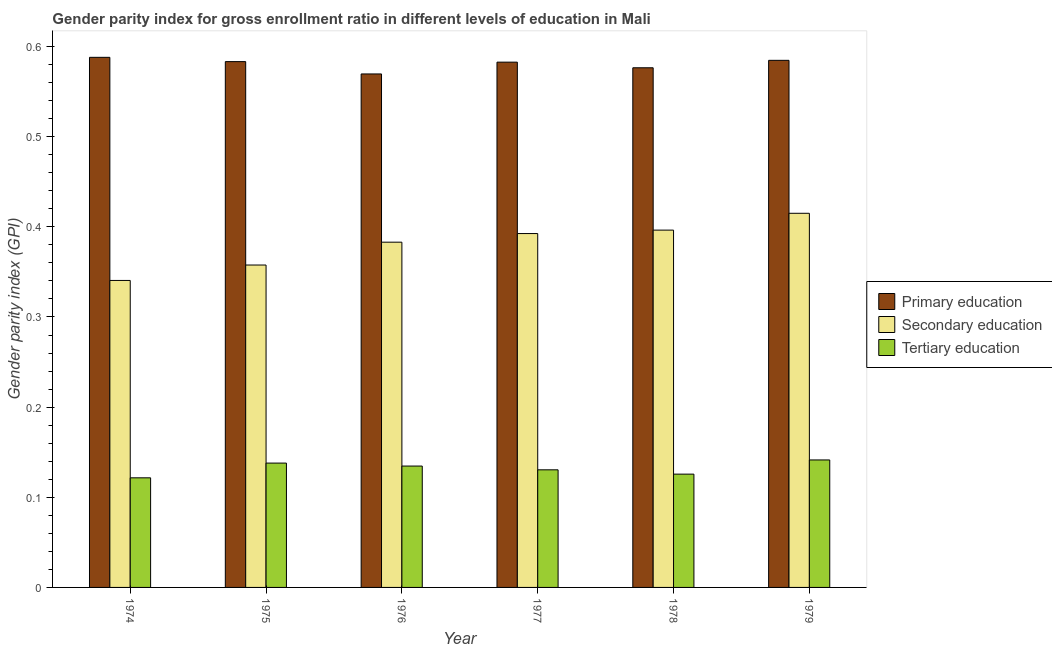How many groups of bars are there?
Your answer should be very brief. 6. Are the number of bars on each tick of the X-axis equal?
Provide a short and direct response. Yes. How many bars are there on the 6th tick from the right?
Make the answer very short. 3. What is the label of the 5th group of bars from the left?
Offer a very short reply. 1978. What is the gender parity index in primary education in 1978?
Offer a terse response. 0.58. Across all years, what is the maximum gender parity index in primary education?
Keep it short and to the point. 0.59. Across all years, what is the minimum gender parity index in primary education?
Make the answer very short. 0.57. In which year was the gender parity index in primary education maximum?
Ensure brevity in your answer.  1974. In which year was the gender parity index in secondary education minimum?
Ensure brevity in your answer.  1974. What is the total gender parity index in secondary education in the graph?
Your answer should be compact. 2.29. What is the difference between the gender parity index in primary education in 1974 and that in 1979?
Keep it short and to the point. 0. What is the difference between the gender parity index in secondary education in 1975 and the gender parity index in primary education in 1976?
Provide a succinct answer. -0.03. What is the average gender parity index in primary education per year?
Your response must be concise. 0.58. In the year 1974, what is the difference between the gender parity index in secondary education and gender parity index in primary education?
Provide a succinct answer. 0. In how many years, is the gender parity index in primary education greater than 0.22?
Keep it short and to the point. 6. What is the ratio of the gender parity index in secondary education in 1975 to that in 1977?
Your answer should be very brief. 0.91. Is the gender parity index in tertiary education in 1977 less than that in 1978?
Your answer should be compact. No. What is the difference between the highest and the second highest gender parity index in secondary education?
Make the answer very short. 0.02. What is the difference between the highest and the lowest gender parity index in secondary education?
Offer a very short reply. 0.07. In how many years, is the gender parity index in tertiary education greater than the average gender parity index in tertiary education taken over all years?
Your response must be concise. 3. Is the sum of the gender parity index in tertiary education in 1974 and 1976 greater than the maximum gender parity index in primary education across all years?
Your answer should be very brief. Yes. What does the 2nd bar from the left in 1979 represents?
Your response must be concise. Secondary education. What does the 3rd bar from the right in 1976 represents?
Give a very brief answer. Primary education. Is it the case that in every year, the sum of the gender parity index in primary education and gender parity index in secondary education is greater than the gender parity index in tertiary education?
Offer a very short reply. Yes. How many years are there in the graph?
Offer a terse response. 6. What is the difference between two consecutive major ticks on the Y-axis?
Keep it short and to the point. 0.1. Are the values on the major ticks of Y-axis written in scientific E-notation?
Offer a very short reply. No. Does the graph contain grids?
Offer a very short reply. No. How many legend labels are there?
Make the answer very short. 3. How are the legend labels stacked?
Ensure brevity in your answer.  Vertical. What is the title of the graph?
Give a very brief answer. Gender parity index for gross enrollment ratio in different levels of education in Mali. What is the label or title of the X-axis?
Your response must be concise. Year. What is the label or title of the Y-axis?
Ensure brevity in your answer.  Gender parity index (GPI). What is the Gender parity index (GPI) in Primary education in 1974?
Your answer should be very brief. 0.59. What is the Gender parity index (GPI) of Secondary education in 1974?
Offer a terse response. 0.34. What is the Gender parity index (GPI) in Tertiary education in 1974?
Your answer should be very brief. 0.12. What is the Gender parity index (GPI) of Primary education in 1975?
Offer a very short reply. 0.58. What is the Gender parity index (GPI) of Secondary education in 1975?
Your answer should be very brief. 0.36. What is the Gender parity index (GPI) in Tertiary education in 1975?
Give a very brief answer. 0.14. What is the Gender parity index (GPI) of Primary education in 1976?
Your response must be concise. 0.57. What is the Gender parity index (GPI) in Secondary education in 1976?
Provide a short and direct response. 0.38. What is the Gender parity index (GPI) of Tertiary education in 1976?
Keep it short and to the point. 0.13. What is the Gender parity index (GPI) of Primary education in 1977?
Provide a succinct answer. 0.58. What is the Gender parity index (GPI) in Secondary education in 1977?
Offer a terse response. 0.39. What is the Gender parity index (GPI) of Tertiary education in 1977?
Your response must be concise. 0.13. What is the Gender parity index (GPI) of Primary education in 1978?
Your answer should be very brief. 0.58. What is the Gender parity index (GPI) in Secondary education in 1978?
Offer a very short reply. 0.4. What is the Gender parity index (GPI) in Tertiary education in 1978?
Ensure brevity in your answer.  0.13. What is the Gender parity index (GPI) of Primary education in 1979?
Offer a very short reply. 0.58. What is the Gender parity index (GPI) in Secondary education in 1979?
Provide a short and direct response. 0.42. What is the Gender parity index (GPI) in Tertiary education in 1979?
Your response must be concise. 0.14. Across all years, what is the maximum Gender parity index (GPI) in Primary education?
Your answer should be compact. 0.59. Across all years, what is the maximum Gender parity index (GPI) of Secondary education?
Provide a short and direct response. 0.42. Across all years, what is the maximum Gender parity index (GPI) of Tertiary education?
Ensure brevity in your answer.  0.14. Across all years, what is the minimum Gender parity index (GPI) in Primary education?
Offer a very short reply. 0.57. Across all years, what is the minimum Gender parity index (GPI) in Secondary education?
Provide a succinct answer. 0.34. Across all years, what is the minimum Gender parity index (GPI) of Tertiary education?
Give a very brief answer. 0.12. What is the total Gender parity index (GPI) of Primary education in the graph?
Give a very brief answer. 3.48. What is the total Gender parity index (GPI) of Secondary education in the graph?
Your answer should be very brief. 2.29. What is the total Gender parity index (GPI) of Tertiary education in the graph?
Keep it short and to the point. 0.79. What is the difference between the Gender parity index (GPI) in Primary education in 1974 and that in 1975?
Your answer should be compact. 0. What is the difference between the Gender parity index (GPI) of Secondary education in 1974 and that in 1975?
Your response must be concise. -0.02. What is the difference between the Gender parity index (GPI) in Tertiary education in 1974 and that in 1975?
Keep it short and to the point. -0.02. What is the difference between the Gender parity index (GPI) in Primary education in 1974 and that in 1976?
Provide a short and direct response. 0.02. What is the difference between the Gender parity index (GPI) in Secondary education in 1974 and that in 1976?
Your answer should be very brief. -0.04. What is the difference between the Gender parity index (GPI) in Tertiary education in 1974 and that in 1976?
Make the answer very short. -0.01. What is the difference between the Gender parity index (GPI) of Primary education in 1974 and that in 1977?
Keep it short and to the point. 0.01. What is the difference between the Gender parity index (GPI) of Secondary education in 1974 and that in 1977?
Ensure brevity in your answer.  -0.05. What is the difference between the Gender parity index (GPI) of Tertiary education in 1974 and that in 1977?
Offer a terse response. -0.01. What is the difference between the Gender parity index (GPI) in Primary education in 1974 and that in 1978?
Ensure brevity in your answer.  0.01. What is the difference between the Gender parity index (GPI) of Secondary education in 1974 and that in 1978?
Make the answer very short. -0.06. What is the difference between the Gender parity index (GPI) of Tertiary education in 1974 and that in 1978?
Your response must be concise. -0. What is the difference between the Gender parity index (GPI) of Primary education in 1974 and that in 1979?
Your answer should be compact. 0. What is the difference between the Gender parity index (GPI) of Secondary education in 1974 and that in 1979?
Provide a succinct answer. -0.07. What is the difference between the Gender parity index (GPI) of Tertiary education in 1974 and that in 1979?
Your response must be concise. -0.02. What is the difference between the Gender parity index (GPI) of Primary education in 1975 and that in 1976?
Your answer should be compact. 0.01. What is the difference between the Gender parity index (GPI) of Secondary education in 1975 and that in 1976?
Ensure brevity in your answer.  -0.03. What is the difference between the Gender parity index (GPI) of Tertiary education in 1975 and that in 1976?
Offer a terse response. 0. What is the difference between the Gender parity index (GPI) of Primary education in 1975 and that in 1977?
Your response must be concise. 0. What is the difference between the Gender parity index (GPI) of Secondary education in 1975 and that in 1977?
Offer a very short reply. -0.03. What is the difference between the Gender parity index (GPI) in Tertiary education in 1975 and that in 1977?
Your answer should be compact. 0.01. What is the difference between the Gender parity index (GPI) of Primary education in 1975 and that in 1978?
Provide a succinct answer. 0.01. What is the difference between the Gender parity index (GPI) in Secondary education in 1975 and that in 1978?
Your answer should be very brief. -0.04. What is the difference between the Gender parity index (GPI) in Tertiary education in 1975 and that in 1978?
Make the answer very short. 0.01. What is the difference between the Gender parity index (GPI) of Primary education in 1975 and that in 1979?
Keep it short and to the point. -0. What is the difference between the Gender parity index (GPI) in Secondary education in 1975 and that in 1979?
Your answer should be compact. -0.06. What is the difference between the Gender parity index (GPI) of Tertiary education in 1975 and that in 1979?
Your answer should be compact. -0. What is the difference between the Gender parity index (GPI) of Primary education in 1976 and that in 1977?
Keep it short and to the point. -0.01. What is the difference between the Gender parity index (GPI) of Secondary education in 1976 and that in 1977?
Provide a succinct answer. -0.01. What is the difference between the Gender parity index (GPI) in Tertiary education in 1976 and that in 1977?
Provide a succinct answer. 0. What is the difference between the Gender parity index (GPI) of Primary education in 1976 and that in 1978?
Your response must be concise. -0.01. What is the difference between the Gender parity index (GPI) in Secondary education in 1976 and that in 1978?
Provide a succinct answer. -0.01. What is the difference between the Gender parity index (GPI) of Tertiary education in 1976 and that in 1978?
Give a very brief answer. 0.01. What is the difference between the Gender parity index (GPI) of Primary education in 1976 and that in 1979?
Keep it short and to the point. -0.02. What is the difference between the Gender parity index (GPI) of Secondary education in 1976 and that in 1979?
Ensure brevity in your answer.  -0.03. What is the difference between the Gender parity index (GPI) in Tertiary education in 1976 and that in 1979?
Keep it short and to the point. -0.01. What is the difference between the Gender parity index (GPI) of Primary education in 1977 and that in 1978?
Offer a terse response. 0.01. What is the difference between the Gender parity index (GPI) of Secondary education in 1977 and that in 1978?
Offer a terse response. -0. What is the difference between the Gender parity index (GPI) of Tertiary education in 1977 and that in 1978?
Give a very brief answer. 0. What is the difference between the Gender parity index (GPI) of Primary education in 1977 and that in 1979?
Make the answer very short. -0. What is the difference between the Gender parity index (GPI) of Secondary education in 1977 and that in 1979?
Provide a short and direct response. -0.02. What is the difference between the Gender parity index (GPI) in Tertiary education in 1977 and that in 1979?
Provide a short and direct response. -0.01. What is the difference between the Gender parity index (GPI) of Primary education in 1978 and that in 1979?
Provide a short and direct response. -0.01. What is the difference between the Gender parity index (GPI) in Secondary education in 1978 and that in 1979?
Ensure brevity in your answer.  -0.02. What is the difference between the Gender parity index (GPI) of Tertiary education in 1978 and that in 1979?
Make the answer very short. -0.02. What is the difference between the Gender parity index (GPI) in Primary education in 1974 and the Gender parity index (GPI) in Secondary education in 1975?
Your answer should be compact. 0.23. What is the difference between the Gender parity index (GPI) of Primary education in 1974 and the Gender parity index (GPI) of Tertiary education in 1975?
Make the answer very short. 0.45. What is the difference between the Gender parity index (GPI) in Secondary education in 1974 and the Gender parity index (GPI) in Tertiary education in 1975?
Your answer should be very brief. 0.2. What is the difference between the Gender parity index (GPI) in Primary education in 1974 and the Gender parity index (GPI) in Secondary education in 1976?
Give a very brief answer. 0.21. What is the difference between the Gender parity index (GPI) in Primary education in 1974 and the Gender parity index (GPI) in Tertiary education in 1976?
Provide a succinct answer. 0.45. What is the difference between the Gender parity index (GPI) of Secondary education in 1974 and the Gender parity index (GPI) of Tertiary education in 1976?
Provide a short and direct response. 0.21. What is the difference between the Gender parity index (GPI) of Primary education in 1974 and the Gender parity index (GPI) of Secondary education in 1977?
Your answer should be compact. 0.2. What is the difference between the Gender parity index (GPI) in Primary education in 1974 and the Gender parity index (GPI) in Tertiary education in 1977?
Give a very brief answer. 0.46. What is the difference between the Gender parity index (GPI) of Secondary education in 1974 and the Gender parity index (GPI) of Tertiary education in 1977?
Provide a succinct answer. 0.21. What is the difference between the Gender parity index (GPI) in Primary education in 1974 and the Gender parity index (GPI) in Secondary education in 1978?
Your answer should be very brief. 0.19. What is the difference between the Gender parity index (GPI) of Primary education in 1974 and the Gender parity index (GPI) of Tertiary education in 1978?
Your answer should be very brief. 0.46. What is the difference between the Gender parity index (GPI) in Secondary education in 1974 and the Gender parity index (GPI) in Tertiary education in 1978?
Keep it short and to the point. 0.21. What is the difference between the Gender parity index (GPI) in Primary education in 1974 and the Gender parity index (GPI) in Secondary education in 1979?
Ensure brevity in your answer.  0.17. What is the difference between the Gender parity index (GPI) of Primary education in 1974 and the Gender parity index (GPI) of Tertiary education in 1979?
Keep it short and to the point. 0.45. What is the difference between the Gender parity index (GPI) in Secondary education in 1974 and the Gender parity index (GPI) in Tertiary education in 1979?
Offer a terse response. 0.2. What is the difference between the Gender parity index (GPI) in Primary education in 1975 and the Gender parity index (GPI) in Secondary education in 1976?
Your response must be concise. 0.2. What is the difference between the Gender parity index (GPI) in Primary education in 1975 and the Gender parity index (GPI) in Tertiary education in 1976?
Offer a terse response. 0.45. What is the difference between the Gender parity index (GPI) in Secondary education in 1975 and the Gender parity index (GPI) in Tertiary education in 1976?
Your answer should be very brief. 0.22. What is the difference between the Gender parity index (GPI) in Primary education in 1975 and the Gender parity index (GPI) in Secondary education in 1977?
Your answer should be very brief. 0.19. What is the difference between the Gender parity index (GPI) of Primary education in 1975 and the Gender parity index (GPI) of Tertiary education in 1977?
Your response must be concise. 0.45. What is the difference between the Gender parity index (GPI) in Secondary education in 1975 and the Gender parity index (GPI) in Tertiary education in 1977?
Ensure brevity in your answer.  0.23. What is the difference between the Gender parity index (GPI) in Primary education in 1975 and the Gender parity index (GPI) in Secondary education in 1978?
Your answer should be very brief. 0.19. What is the difference between the Gender parity index (GPI) in Primary education in 1975 and the Gender parity index (GPI) in Tertiary education in 1978?
Ensure brevity in your answer.  0.46. What is the difference between the Gender parity index (GPI) in Secondary education in 1975 and the Gender parity index (GPI) in Tertiary education in 1978?
Your answer should be very brief. 0.23. What is the difference between the Gender parity index (GPI) in Primary education in 1975 and the Gender parity index (GPI) in Secondary education in 1979?
Give a very brief answer. 0.17. What is the difference between the Gender parity index (GPI) in Primary education in 1975 and the Gender parity index (GPI) in Tertiary education in 1979?
Keep it short and to the point. 0.44. What is the difference between the Gender parity index (GPI) in Secondary education in 1975 and the Gender parity index (GPI) in Tertiary education in 1979?
Make the answer very short. 0.22. What is the difference between the Gender parity index (GPI) in Primary education in 1976 and the Gender parity index (GPI) in Secondary education in 1977?
Your answer should be very brief. 0.18. What is the difference between the Gender parity index (GPI) of Primary education in 1976 and the Gender parity index (GPI) of Tertiary education in 1977?
Make the answer very short. 0.44. What is the difference between the Gender parity index (GPI) of Secondary education in 1976 and the Gender parity index (GPI) of Tertiary education in 1977?
Provide a succinct answer. 0.25. What is the difference between the Gender parity index (GPI) in Primary education in 1976 and the Gender parity index (GPI) in Secondary education in 1978?
Your answer should be very brief. 0.17. What is the difference between the Gender parity index (GPI) in Primary education in 1976 and the Gender parity index (GPI) in Tertiary education in 1978?
Keep it short and to the point. 0.44. What is the difference between the Gender parity index (GPI) in Secondary education in 1976 and the Gender parity index (GPI) in Tertiary education in 1978?
Keep it short and to the point. 0.26. What is the difference between the Gender parity index (GPI) in Primary education in 1976 and the Gender parity index (GPI) in Secondary education in 1979?
Give a very brief answer. 0.15. What is the difference between the Gender parity index (GPI) in Primary education in 1976 and the Gender parity index (GPI) in Tertiary education in 1979?
Give a very brief answer. 0.43. What is the difference between the Gender parity index (GPI) in Secondary education in 1976 and the Gender parity index (GPI) in Tertiary education in 1979?
Give a very brief answer. 0.24. What is the difference between the Gender parity index (GPI) of Primary education in 1977 and the Gender parity index (GPI) of Secondary education in 1978?
Your response must be concise. 0.19. What is the difference between the Gender parity index (GPI) of Primary education in 1977 and the Gender parity index (GPI) of Tertiary education in 1978?
Offer a terse response. 0.46. What is the difference between the Gender parity index (GPI) in Secondary education in 1977 and the Gender parity index (GPI) in Tertiary education in 1978?
Your answer should be very brief. 0.27. What is the difference between the Gender parity index (GPI) in Primary education in 1977 and the Gender parity index (GPI) in Secondary education in 1979?
Provide a succinct answer. 0.17. What is the difference between the Gender parity index (GPI) in Primary education in 1977 and the Gender parity index (GPI) in Tertiary education in 1979?
Ensure brevity in your answer.  0.44. What is the difference between the Gender parity index (GPI) in Secondary education in 1977 and the Gender parity index (GPI) in Tertiary education in 1979?
Provide a succinct answer. 0.25. What is the difference between the Gender parity index (GPI) of Primary education in 1978 and the Gender parity index (GPI) of Secondary education in 1979?
Ensure brevity in your answer.  0.16. What is the difference between the Gender parity index (GPI) of Primary education in 1978 and the Gender parity index (GPI) of Tertiary education in 1979?
Provide a succinct answer. 0.43. What is the difference between the Gender parity index (GPI) in Secondary education in 1978 and the Gender parity index (GPI) in Tertiary education in 1979?
Ensure brevity in your answer.  0.25. What is the average Gender parity index (GPI) of Primary education per year?
Give a very brief answer. 0.58. What is the average Gender parity index (GPI) in Secondary education per year?
Offer a very short reply. 0.38. What is the average Gender parity index (GPI) of Tertiary education per year?
Keep it short and to the point. 0.13. In the year 1974, what is the difference between the Gender parity index (GPI) of Primary education and Gender parity index (GPI) of Secondary education?
Your answer should be compact. 0.25. In the year 1974, what is the difference between the Gender parity index (GPI) of Primary education and Gender parity index (GPI) of Tertiary education?
Make the answer very short. 0.47. In the year 1974, what is the difference between the Gender parity index (GPI) of Secondary education and Gender parity index (GPI) of Tertiary education?
Offer a very short reply. 0.22. In the year 1975, what is the difference between the Gender parity index (GPI) of Primary education and Gender parity index (GPI) of Secondary education?
Your answer should be compact. 0.23. In the year 1975, what is the difference between the Gender parity index (GPI) of Primary education and Gender parity index (GPI) of Tertiary education?
Provide a short and direct response. 0.45. In the year 1975, what is the difference between the Gender parity index (GPI) in Secondary education and Gender parity index (GPI) in Tertiary education?
Your response must be concise. 0.22. In the year 1976, what is the difference between the Gender parity index (GPI) of Primary education and Gender parity index (GPI) of Secondary education?
Offer a terse response. 0.19. In the year 1976, what is the difference between the Gender parity index (GPI) of Primary education and Gender parity index (GPI) of Tertiary education?
Provide a succinct answer. 0.43. In the year 1976, what is the difference between the Gender parity index (GPI) of Secondary education and Gender parity index (GPI) of Tertiary education?
Ensure brevity in your answer.  0.25. In the year 1977, what is the difference between the Gender parity index (GPI) of Primary education and Gender parity index (GPI) of Secondary education?
Give a very brief answer. 0.19. In the year 1977, what is the difference between the Gender parity index (GPI) of Primary education and Gender parity index (GPI) of Tertiary education?
Offer a very short reply. 0.45. In the year 1977, what is the difference between the Gender parity index (GPI) of Secondary education and Gender parity index (GPI) of Tertiary education?
Keep it short and to the point. 0.26. In the year 1978, what is the difference between the Gender parity index (GPI) in Primary education and Gender parity index (GPI) in Secondary education?
Your response must be concise. 0.18. In the year 1978, what is the difference between the Gender parity index (GPI) of Primary education and Gender parity index (GPI) of Tertiary education?
Offer a very short reply. 0.45. In the year 1978, what is the difference between the Gender parity index (GPI) of Secondary education and Gender parity index (GPI) of Tertiary education?
Provide a short and direct response. 0.27. In the year 1979, what is the difference between the Gender parity index (GPI) in Primary education and Gender parity index (GPI) in Secondary education?
Your answer should be compact. 0.17. In the year 1979, what is the difference between the Gender parity index (GPI) in Primary education and Gender parity index (GPI) in Tertiary education?
Provide a succinct answer. 0.44. In the year 1979, what is the difference between the Gender parity index (GPI) in Secondary education and Gender parity index (GPI) in Tertiary education?
Keep it short and to the point. 0.27. What is the ratio of the Gender parity index (GPI) of Primary education in 1974 to that in 1975?
Keep it short and to the point. 1.01. What is the ratio of the Gender parity index (GPI) of Secondary education in 1974 to that in 1975?
Provide a short and direct response. 0.95. What is the ratio of the Gender parity index (GPI) of Tertiary education in 1974 to that in 1975?
Provide a short and direct response. 0.88. What is the ratio of the Gender parity index (GPI) of Primary education in 1974 to that in 1976?
Ensure brevity in your answer.  1.03. What is the ratio of the Gender parity index (GPI) of Secondary education in 1974 to that in 1976?
Your response must be concise. 0.89. What is the ratio of the Gender parity index (GPI) of Tertiary education in 1974 to that in 1976?
Ensure brevity in your answer.  0.9. What is the ratio of the Gender parity index (GPI) in Primary education in 1974 to that in 1977?
Ensure brevity in your answer.  1.01. What is the ratio of the Gender parity index (GPI) in Secondary education in 1974 to that in 1977?
Offer a very short reply. 0.87. What is the ratio of the Gender parity index (GPI) in Tertiary education in 1974 to that in 1977?
Keep it short and to the point. 0.93. What is the ratio of the Gender parity index (GPI) of Primary education in 1974 to that in 1978?
Offer a very short reply. 1.02. What is the ratio of the Gender parity index (GPI) in Secondary education in 1974 to that in 1978?
Keep it short and to the point. 0.86. What is the ratio of the Gender parity index (GPI) of Tertiary education in 1974 to that in 1978?
Your answer should be compact. 0.97. What is the ratio of the Gender parity index (GPI) of Secondary education in 1974 to that in 1979?
Offer a very short reply. 0.82. What is the ratio of the Gender parity index (GPI) in Tertiary education in 1974 to that in 1979?
Provide a succinct answer. 0.86. What is the ratio of the Gender parity index (GPI) of Secondary education in 1975 to that in 1976?
Make the answer very short. 0.93. What is the ratio of the Gender parity index (GPI) in Tertiary education in 1975 to that in 1976?
Provide a succinct answer. 1.02. What is the ratio of the Gender parity index (GPI) in Primary education in 1975 to that in 1977?
Your response must be concise. 1. What is the ratio of the Gender parity index (GPI) in Secondary education in 1975 to that in 1977?
Your response must be concise. 0.91. What is the ratio of the Gender parity index (GPI) in Tertiary education in 1975 to that in 1977?
Provide a short and direct response. 1.06. What is the ratio of the Gender parity index (GPI) of Primary education in 1975 to that in 1978?
Offer a terse response. 1.01. What is the ratio of the Gender parity index (GPI) in Secondary education in 1975 to that in 1978?
Keep it short and to the point. 0.9. What is the ratio of the Gender parity index (GPI) in Tertiary education in 1975 to that in 1978?
Make the answer very short. 1.1. What is the ratio of the Gender parity index (GPI) of Secondary education in 1975 to that in 1979?
Keep it short and to the point. 0.86. What is the ratio of the Gender parity index (GPI) in Tertiary education in 1975 to that in 1979?
Make the answer very short. 0.98. What is the ratio of the Gender parity index (GPI) in Primary education in 1976 to that in 1977?
Provide a succinct answer. 0.98. What is the ratio of the Gender parity index (GPI) of Secondary education in 1976 to that in 1977?
Offer a terse response. 0.98. What is the ratio of the Gender parity index (GPI) in Tertiary education in 1976 to that in 1977?
Give a very brief answer. 1.03. What is the ratio of the Gender parity index (GPI) in Secondary education in 1976 to that in 1978?
Keep it short and to the point. 0.97. What is the ratio of the Gender parity index (GPI) of Tertiary education in 1976 to that in 1978?
Offer a very short reply. 1.07. What is the ratio of the Gender parity index (GPI) of Primary education in 1976 to that in 1979?
Ensure brevity in your answer.  0.97. What is the ratio of the Gender parity index (GPI) in Secondary education in 1976 to that in 1979?
Provide a short and direct response. 0.92. What is the ratio of the Gender parity index (GPI) in Primary education in 1977 to that in 1978?
Make the answer very short. 1.01. What is the ratio of the Gender parity index (GPI) in Tertiary education in 1977 to that in 1978?
Make the answer very short. 1.04. What is the ratio of the Gender parity index (GPI) of Secondary education in 1977 to that in 1979?
Offer a very short reply. 0.95. What is the ratio of the Gender parity index (GPI) in Tertiary education in 1977 to that in 1979?
Offer a terse response. 0.92. What is the ratio of the Gender parity index (GPI) of Primary education in 1978 to that in 1979?
Your response must be concise. 0.99. What is the ratio of the Gender parity index (GPI) in Secondary education in 1978 to that in 1979?
Ensure brevity in your answer.  0.95. What is the ratio of the Gender parity index (GPI) of Tertiary education in 1978 to that in 1979?
Offer a very short reply. 0.89. What is the difference between the highest and the second highest Gender parity index (GPI) of Primary education?
Offer a very short reply. 0. What is the difference between the highest and the second highest Gender parity index (GPI) in Secondary education?
Offer a very short reply. 0.02. What is the difference between the highest and the second highest Gender parity index (GPI) in Tertiary education?
Your answer should be very brief. 0. What is the difference between the highest and the lowest Gender parity index (GPI) in Primary education?
Keep it short and to the point. 0.02. What is the difference between the highest and the lowest Gender parity index (GPI) of Secondary education?
Make the answer very short. 0.07. What is the difference between the highest and the lowest Gender parity index (GPI) of Tertiary education?
Keep it short and to the point. 0.02. 